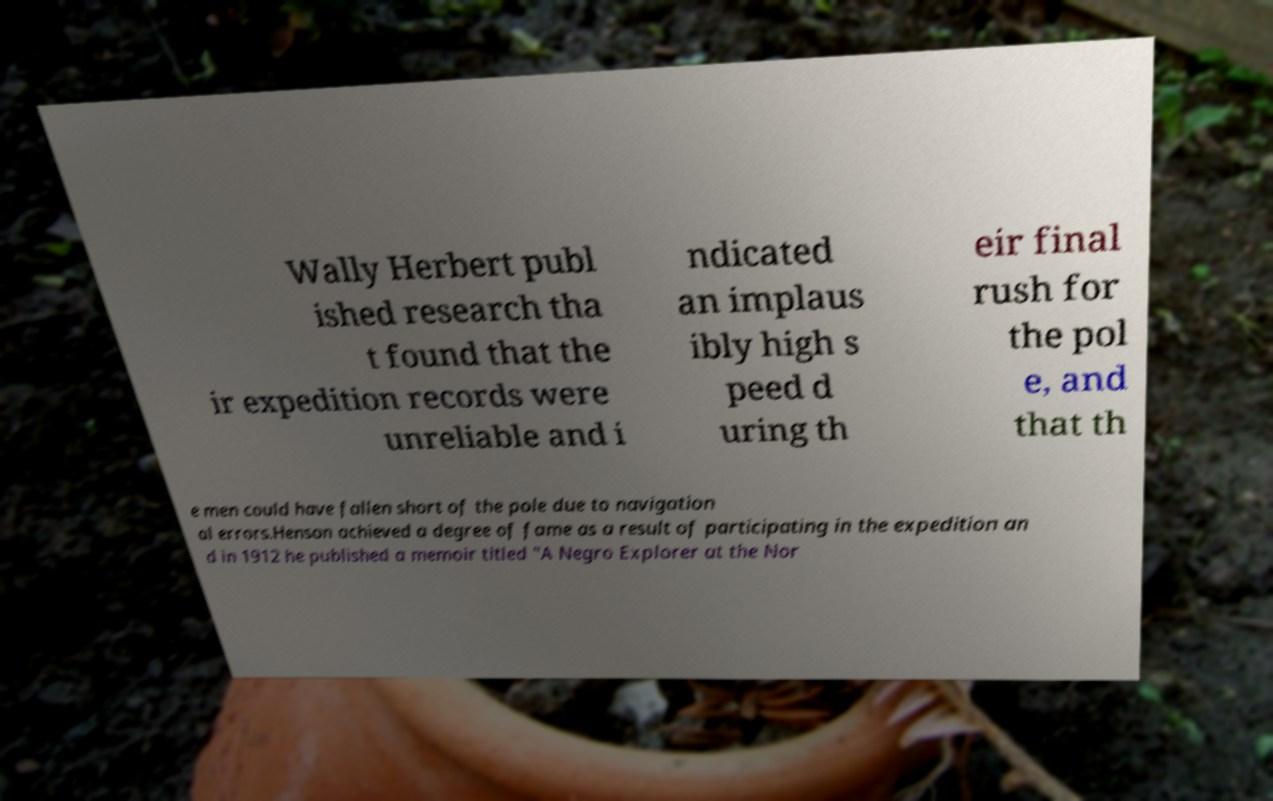I need the written content from this picture converted into text. Can you do that? Wally Herbert publ ished research tha t found that the ir expedition records were unreliable and i ndicated an implaus ibly high s peed d uring th eir final rush for the pol e, and that th e men could have fallen short of the pole due to navigation al errors.Henson achieved a degree of fame as a result of participating in the expedition an d in 1912 he published a memoir titled "A Negro Explorer at the Nor 